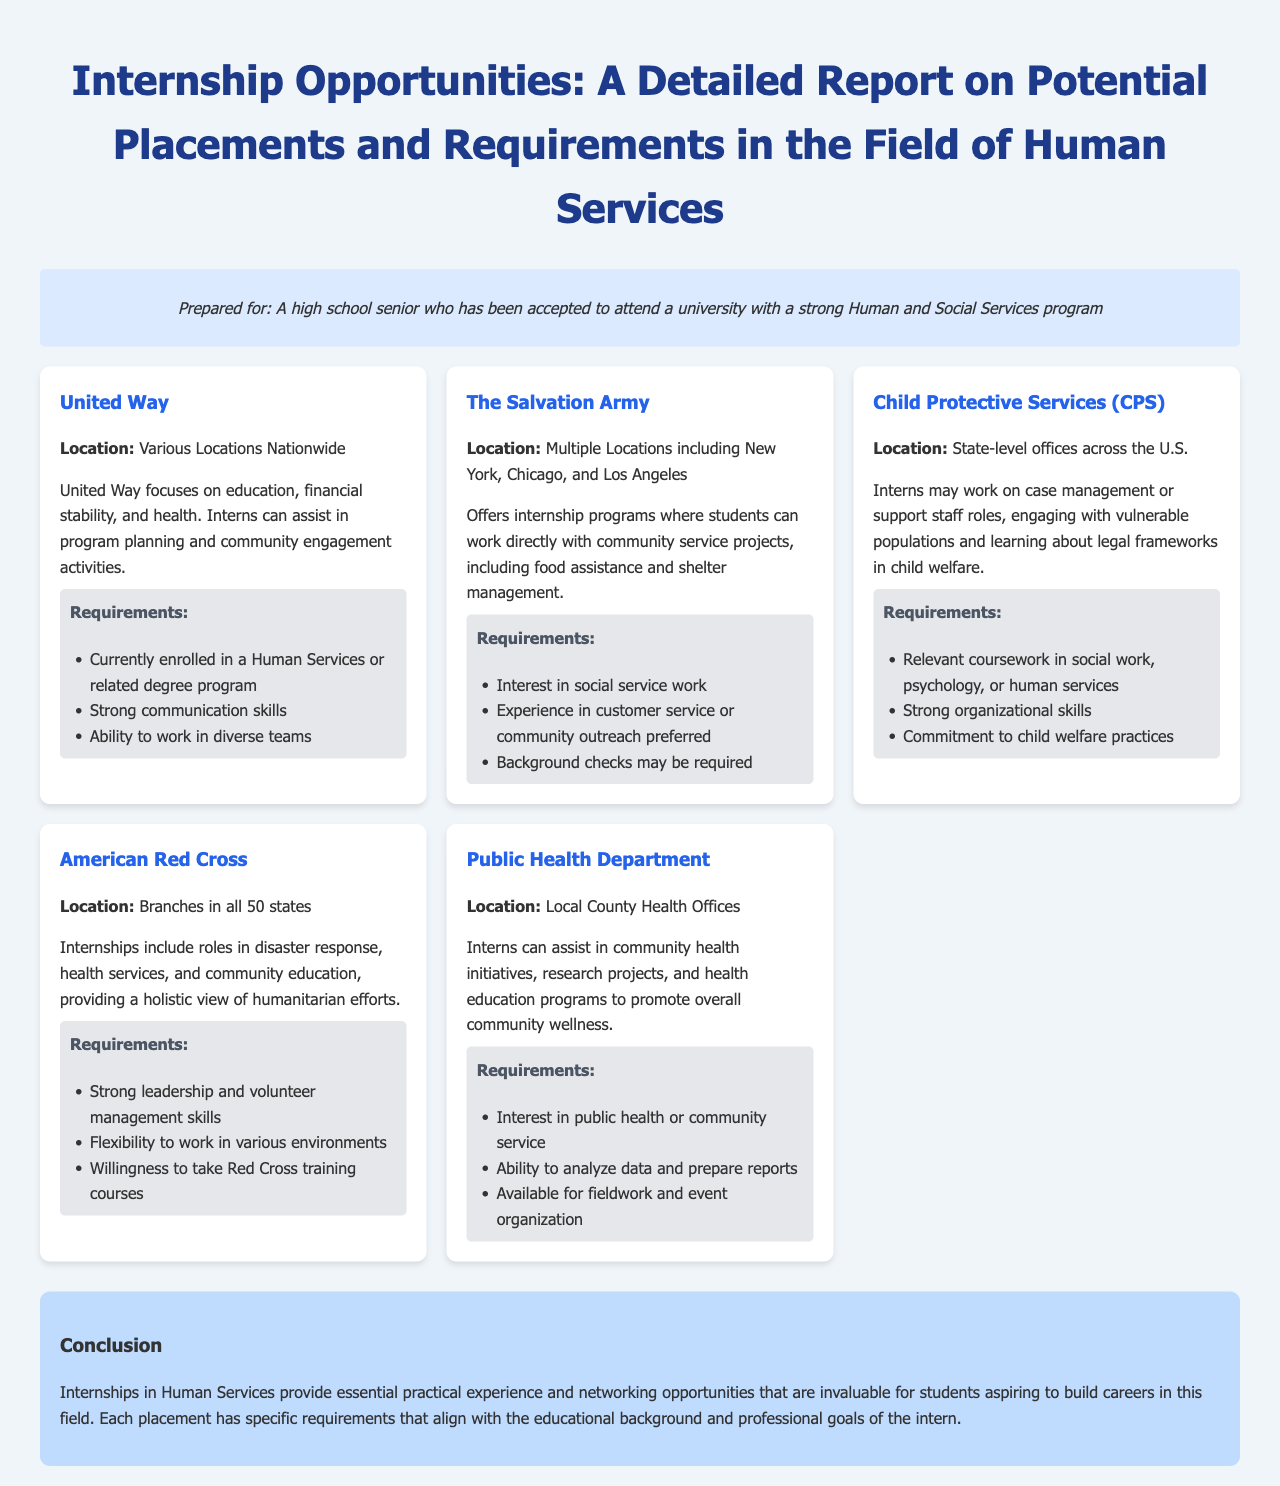What is the organization with internships focused on education, financial stability, and health? The document mentions United Way as the organization focusing on those areas.
Answer: United Way How many locations does The Salvation Army have? The document indicates that The Salvation Army has multiple locations including New York, Chicago, and Los Angeles.
Answer: Multiple Locations What is a requirement for an internship at Child Protective Services? The document states that relevant coursework in social work, psychology, or human services is required for internships at CPS.
Answer: Relevant coursework in social work, psychology, or human services What type of skills are emphasized for the American Red Cross internships? The document highlights strong leadership and volunteer management skills as important for the American Red Cross internships.
Answer: Strong leadership and volunteer management skills What internship focuses on community health initiatives? The Public Health Department internship is mentioned as focusing on community health initiatives.
Answer: Public Health Department What is a common requirement across all internships listed? The document indicates that being currently enrolled in a Human Services or related degree program is a requirement for many internships.
Answer: Currently enrolled in a Human Services or related degree program In which type of roles can interns work at Child Protective Services? Interns at CPS may work on case management or support staff roles as per the document.
Answer: Case management or support staff roles What is mentioned about the conclusion of the report? The conclusion mentions that internships provide essential practical experience and networking opportunities invaluable for students.
Answer: Essential practical experience and networking opportunities 